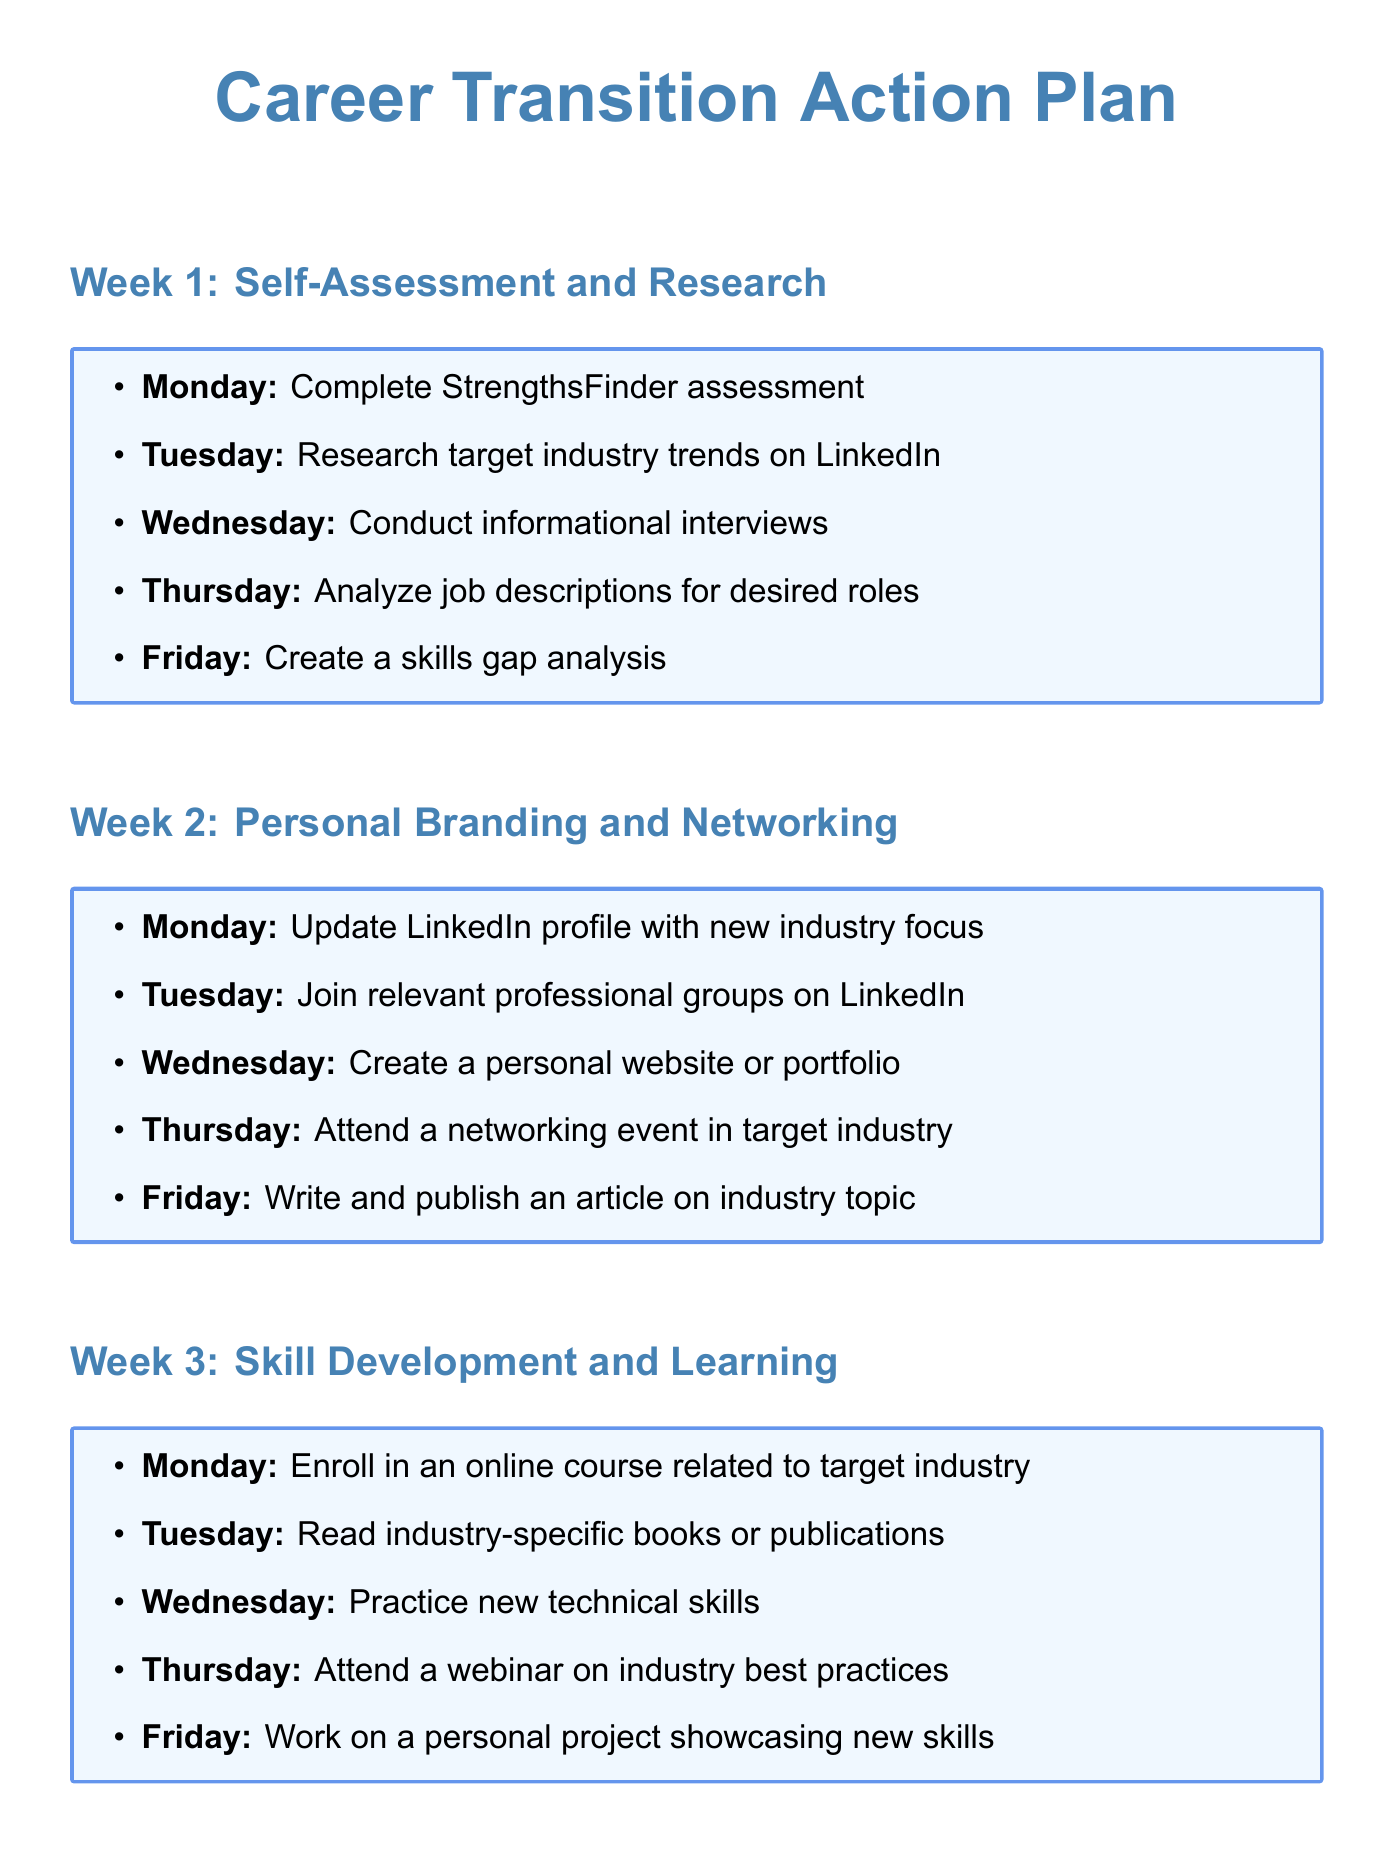What is the theme for week 1? The theme for week 1 is the primary focus of the tasks outlined for that week.
Answer: Self-Assessment and Research How many tasks are assigned for Thursday in week 2? The number of tasks for a specific day is clearly listed under each week's schedule.
Answer: 1 What is the milestone for completing the StrengthsFinder assessment? Milestones are specific goals related to the tasks, indicating successful completion.
Answer: Identify top 5 strengths Which day is dedicated to reading industry-specific books or publications? The document specifies the task scheduled for each day, defining the focus for that day.
Answer: Tuesday What is the total number of weeks in the action plan? The action plan outlines a schedule divided into weeks, indicating its overall duration.
Answer: 4 Which task is assigned to Friday of week 3? Each day has a specific task assigned to ensure structured progress in skill development.
Answer: Work on a personal project showcasing new skills What is the milestone for tailoring the resume? Milestones serve to provide a tangible outcome that reflects the successful execution of a task.
Answer: Create 3 versions for different job types How many professional groups should be joined on Tuesday of week 2? The number of groups to engage with is explicitly indicated in the respective day's task.
Answer: 3 What type of project should be worked on in week 3? The document outlines the focus of development efforts through specific tasks outlined for each day of the week.
Answer: Personal project showcasing new skills 